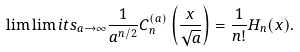Convert formula to latex. <formula><loc_0><loc_0><loc_500><loc_500>\lim \lim i t s _ { a \to \infty } \frac { 1 } { a ^ { n / 2 } } C _ { n } ^ { ( a ) } \left ( \frac { x } { \sqrt { a } } \right ) = \frac { 1 } { n ! } H _ { n } ( x ) .</formula> 